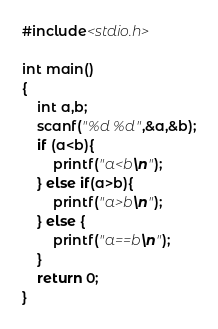Convert code to text. <code><loc_0><loc_0><loc_500><loc_500><_C_>#include<stdio.h>

int main()
{
    int a,b;
    scanf("%d %d",&a,&b);
    if (a<b){
        printf("a<b\n");
    } else if(a>b){
        printf("a>b\n");
    } else {
        printf("a==b\n");
    }
    return 0;
}</code> 